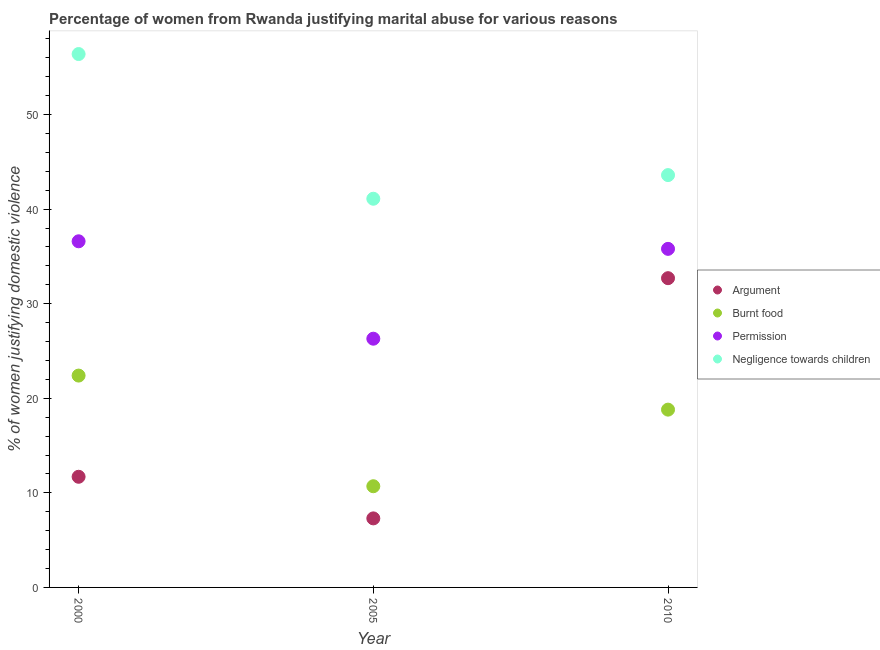What is the percentage of women justifying abuse for going without permission in 2005?
Offer a very short reply. 26.3. Across all years, what is the maximum percentage of women justifying abuse for burning food?
Give a very brief answer. 22.4. Across all years, what is the minimum percentage of women justifying abuse in the case of an argument?
Offer a very short reply. 7.3. In which year was the percentage of women justifying abuse in the case of an argument maximum?
Offer a terse response. 2010. In which year was the percentage of women justifying abuse for burning food minimum?
Offer a very short reply. 2005. What is the total percentage of women justifying abuse for going without permission in the graph?
Give a very brief answer. 98.7. What is the difference between the percentage of women justifying abuse for showing negligence towards children in 2000 and that in 2005?
Provide a succinct answer. 15.3. What is the difference between the percentage of women justifying abuse in the case of an argument in 2010 and the percentage of women justifying abuse for showing negligence towards children in 2000?
Give a very brief answer. -23.7. What is the average percentage of women justifying abuse for going without permission per year?
Ensure brevity in your answer.  32.9. In the year 2010, what is the difference between the percentage of women justifying abuse for burning food and percentage of women justifying abuse for showing negligence towards children?
Keep it short and to the point. -24.8. What is the ratio of the percentage of women justifying abuse for burning food in 2000 to that in 2010?
Offer a terse response. 1.19. Is the percentage of women justifying abuse for burning food in 2000 less than that in 2005?
Make the answer very short. No. What is the difference between the highest and the second highest percentage of women justifying abuse for burning food?
Provide a succinct answer. 3.6. What is the difference between the highest and the lowest percentage of women justifying abuse for showing negligence towards children?
Keep it short and to the point. 15.3. In how many years, is the percentage of women justifying abuse for burning food greater than the average percentage of women justifying abuse for burning food taken over all years?
Your response must be concise. 2. Is the sum of the percentage of women justifying abuse for going without permission in 2000 and 2005 greater than the maximum percentage of women justifying abuse for showing negligence towards children across all years?
Give a very brief answer. Yes. Is it the case that in every year, the sum of the percentage of women justifying abuse in the case of an argument and percentage of women justifying abuse for burning food is greater than the percentage of women justifying abuse for going without permission?
Give a very brief answer. No. Is the percentage of women justifying abuse for going without permission strictly less than the percentage of women justifying abuse in the case of an argument over the years?
Provide a short and direct response. No. What is the difference between two consecutive major ticks on the Y-axis?
Give a very brief answer. 10. Are the values on the major ticks of Y-axis written in scientific E-notation?
Offer a very short reply. No. Does the graph contain grids?
Make the answer very short. No. Where does the legend appear in the graph?
Make the answer very short. Center right. How many legend labels are there?
Keep it short and to the point. 4. What is the title of the graph?
Your response must be concise. Percentage of women from Rwanda justifying marital abuse for various reasons. Does "Burnt food" appear as one of the legend labels in the graph?
Offer a very short reply. Yes. What is the label or title of the Y-axis?
Your answer should be very brief. % of women justifying domestic violence. What is the % of women justifying domestic violence of Burnt food in 2000?
Your answer should be compact. 22.4. What is the % of women justifying domestic violence in Permission in 2000?
Ensure brevity in your answer.  36.6. What is the % of women justifying domestic violence of Negligence towards children in 2000?
Your response must be concise. 56.4. What is the % of women justifying domestic violence in Argument in 2005?
Offer a very short reply. 7.3. What is the % of women justifying domestic violence in Permission in 2005?
Your answer should be compact. 26.3. What is the % of women justifying domestic violence in Negligence towards children in 2005?
Make the answer very short. 41.1. What is the % of women justifying domestic violence in Argument in 2010?
Offer a terse response. 32.7. What is the % of women justifying domestic violence in Permission in 2010?
Your response must be concise. 35.8. What is the % of women justifying domestic violence of Negligence towards children in 2010?
Ensure brevity in your answer.  43.6. Across all years, what is the maximum % of women justifying domestic violence in Argument?
Ensure brevity in your answer.  32.7. Across all years, what is the maximum % of women justifying domestic violence of Burnt food?
Give a very brief answer. 22.4. Across all years, what is the maximum % of women justifying domestic violence in Permission?
Keep it short and to the point. 36.6. Across all years, what is the maximum % of women justifying domestic violence in Negligence towards children?
Offer a very short reply. 56.4. Across all years, what is the minimum % of women justifying domestic violence of Argument?
Offer a very short reply. 7.3. Across all years, what is the minimum % of women justifying domestic violence of Permission?
Offer a terse response. 26.3. Across all years, what is the minimum % of women justifying domestic violence of Negligence towards children?
Offer a terse response. 41.1. What is the total % of women justifying domestic violence of Argument in the graph?
Provide a short and direct response. 51.7. What is the total % of women justifying domestic violence in Burnt food in the graph?
Offer a very short reply. 51.9. What is the total % of women justifying domestic violence of Permission in the graph?
Ensure brevity in your answer.  98.7. What is the total % of women justifying domestic violence in Negligence towards children in the graph?
Ensure brevity in your answer.  141.1. What is the difference between the % of women justifying domestic violence in Argument in 2000 and that in 2005?
Your response must be concise. 4.4. What is the difference between the % of women justifying domestic violence in Permission in 2000 and that in 2010?
Ensure brevity in your answer.  0.8. What is the difference between the % of women justifying domestic violence of Negligence towards children in 2000 and that in 2010?
Provide a short and direct response. 12.8. What is the difference between the % of women justifying domestic violence in Argument in 2005 and that in 2010?
Make the answer very short. -25.4. What is the difference between the % of women justifying domestic violence in Argument in 2000 and the % of women justifying domestic violence in Burnt food in 2005?
Your answer should be very brief. 1. What is the difference between the % of women justifying domestic violence in Argument in 2000 and the % of women justifying domestic violence in Permission in 2005?
Keep it short and to the point. -14.6. What is the difference between the % of women justifying domestic violence of Argument in 2000 and the % of women justifying domestic violence of Negligence towards children in 2005?
Ensure brevity in your answer.  -29.4. What is the difference between the % of women justifying domestic violence of Burnt food in 2000 and the % of women justifying domestic violence of Permission in 2005?
Provide a short and direct response. -3.9. What is the difference between the % of women justifying domestic violence of Burnt food in 2000 and the % of women justifying domestic violence of Negligence towards children in 2005?
Keep it short and to the point. -18.7. What is the difference between the % of women justifying domestic violence of Permission in 2000 and the % of women justifying domestic violence of Negligence towards children in 2005?
Your answer should be very brief. -4.5. What is the difference between the % of women justifying domestic violence of Argument in 2000 and the % of women justifying domestic violence of Permission in 2010?
Provide a succinct answer. -24.1. What is the difference between the % of women justifying domestic violence in Argument in 2000 and the % of women justifying domestic violence in Negligence towards children in 2010?
Provide a short and direct response. -31.9. What is the difference between the % of women justifying domestic violence in Burnt food in 2000 and the % of women justifying domestic violence in Negligence towards children in 2010?
Offer a terse response. -21.2. What is the difference between the % of women justifying domestic violence of Argument in 2005 and the % of women justifying domestic violence of Permission in 2010?
Offer a terse response. -28.5. What is the difference between the % of women justifying domestic violence of Argument in 2005 and the % of women justifying domestic violence of Negligence towards children in 2010?
Your answer should be very brief. -36.3. What is the difference between the % of women justifying domestic violence of Burnt food in 2005 and the % of women justifying domestic violence of Permission in 2010?
Make the answer very short. -25.1. What is the difference between the % of women justifying domestic violence in Burnt food in 2005 and the % of women justifying domestic violence in Negligence towards children in 2010?
Your answer should be compact. -32.9. What is the difference between the % of women justifying domestic violence of Permission in 2005 and the % of women justifying domestic violence of Negligence towards children in 2010?
Your answer should be compact. -17.3. What is the average % of women justifying domestic violence in Argument per year?
Ensure brevity in your answer.  17.23. What is the average % of women justifying domestic violence of Burnt food per year?
Ensure brevity in your answer.  17.3. What is the average % of women justifying domestic violence of Permission per year?
Your answer should be very brief. 32.9. What is the average % of women justifying domestic violence of Negligence towards children per year?
Ensure brevity in your answer.  47.03. In the year 2000, what is the difference between the % of women justifying domestic violence of Argument and % of women justifying domestic violence of Burnt food?
Your answer should be very brief. -10.7. In the year 2000, what is the difference between the % of women justifying domestic violence of Argument and % of women justifying domestic violence of Permission?
Make the answer very short. -24.9. In the year 2000, what is the difference between the % of women justifying domestic violence in Argument and % of women justifying domestic violence in Negligence towards children?
Your response must be concise. -44.7. In the year 2000, what is the difference between the % of women justifying domestic violence of Burnt food and % of women justifying domestic violence of Permission?
Keep it short and to the point. -14.2. In the year 2000, what is the difference between the % of women justifying domestic violence of Burnt food and % of women justifying domestic violence of Negligence towards children?
Provide a short and direct response. -34. In the year 2000, what is the difference between the % of women justifying domestic violence in Permission and % of women justifying domestic violence in Negligence towards children?
Provide a succinct answer. -19.8. In the year 2005, what is the difference between the % of women justifying domestic violence of Argument and % of women justifying domestic violence of Burnt food?
Provide a short and direct response. -3.4. In the year 2005, what is the difference between the % of women justifying domestic violence in Argument and % of women justifying domestic violence in Permission?
Your response must be concise. -19. In the year 2005, what is the difference between the % of women justifying domestic violence in Argument and % of women justifying domestic violence in Negligence towards children?
Provide a short and direct response. -33.8. In the year 2005, what is the difference between the % of women justifying domestic violence of Burnt food and % of women justifying domestic violence of Permission?
Ensure brevity in your answer.  -15.6. In the year 2005, what is the difference between the % of women justifying domestic violence in Burnt food and % of women justifying domestic violence in Negligence towards children?
Keep it short and to the point. -30.4. In the year 2005, what is the difference between the % of women justifying domestic violence in Permission and % of women justifying domestic violence in Negligence towards children?
Keep it short and to the point. -14.8. In the year 2010, what is the difference between the % of women justifying domestic violence in Burnt food and % of women justifying domestic violence in Permission?
Offer a very short reply. -17. In the year 2010, what is the difference between the % of women justifying domestic violence in Burnt food and % of women justifying domestic violence in Negligence towards children?
Make the answer very short. -24.8. In the year 2010, what is the difference between the % of women justifying domestic violence of Permission and % of women justifying domestic violence of Negligence towards children?
Provide a succinct answer. -7.8. What is the ratio of the % of women justifying domestic violence of Argument in 2000 to that in 2005?
Offer a very short reply. 1.6. What is the ratio of the % of women justifying domestic violence in Burnt food in 2000 to that in 2005?
Offer a very short reply. 2.09. What is the ratio of the % of women justifying domestic violence of Permission in 2000 to that in 2005?
Offer a terse response. 1.39. What is the ratio of the % of women justifying domestic violence in Negligence towards children in 2000 to that in 2005?
Offer a terse response. 1.37. What is the ratio of the % of women justifying domestic violence of Argument in 2000 to that in 2010?
Your response must be concise. 0.36. What is the ratio of the % of women justifying domestic violence of Burnt food in 2000 to that in 2010?
Your answer should be compact. 1.19. What is the ratio of the % of women justifying domestic violence of Permission in 2000 to that in 2010?
Provide a succinct answer. 1.02. What is the ratio of the % of women justifying domestic violence of Negligence towards children in 2000 to that in 2010?
Provide a succinct answer. 1.29. What is the ratio of the % of women justifying domestic violence in Argument in 2005 to that in 2010?
Give a very brief answer. 0.22. What is the ratio of the % of women justifying domestic violence in Burnt food in 2005 to that in 2010?
Your answer should be compact. 0.57. What is the ratio of the % of women justifying domestic violence of Permission in 2005 to that in 2010?
Provide a short and direct response. 0.73. What is the ratio of the % of women justifying domestic violence in Negligence towards children in 2005 to that in 2010?
Give a very brief answer. 0.94. What is the difference between the highest and the second highest % of women justifying domestic violence in Argument?
Ensure brevity in your answer.  21. What is the difference between the highest and the lowest % of women justifying domestic violence in Argument?
Your answer should be very brief. 25.4. What is the difference between the highest and the lowest % of women justifying domestic violence in Permission?
Keep it short and to the point. 10.3. 